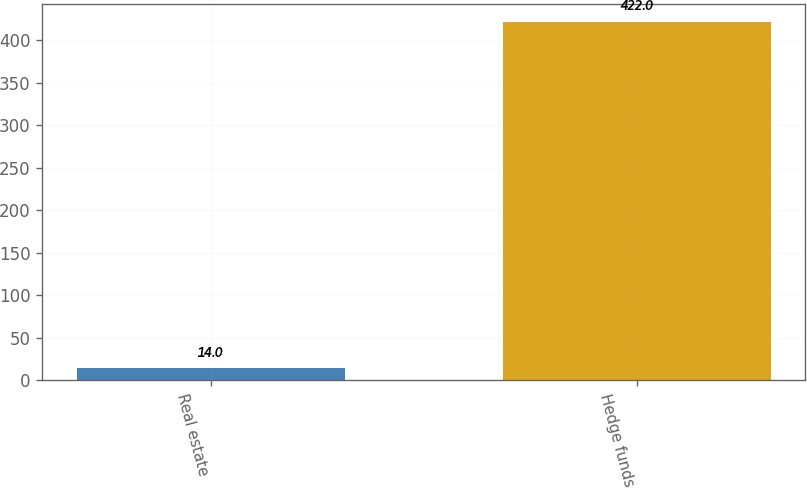<chart> <loc_0><loc_0><loc_500><loc_500><bar_chart><fcel>Real estate<fcel>Hedge funds<nl><fcel>14<fcel>422<nl></chart> 